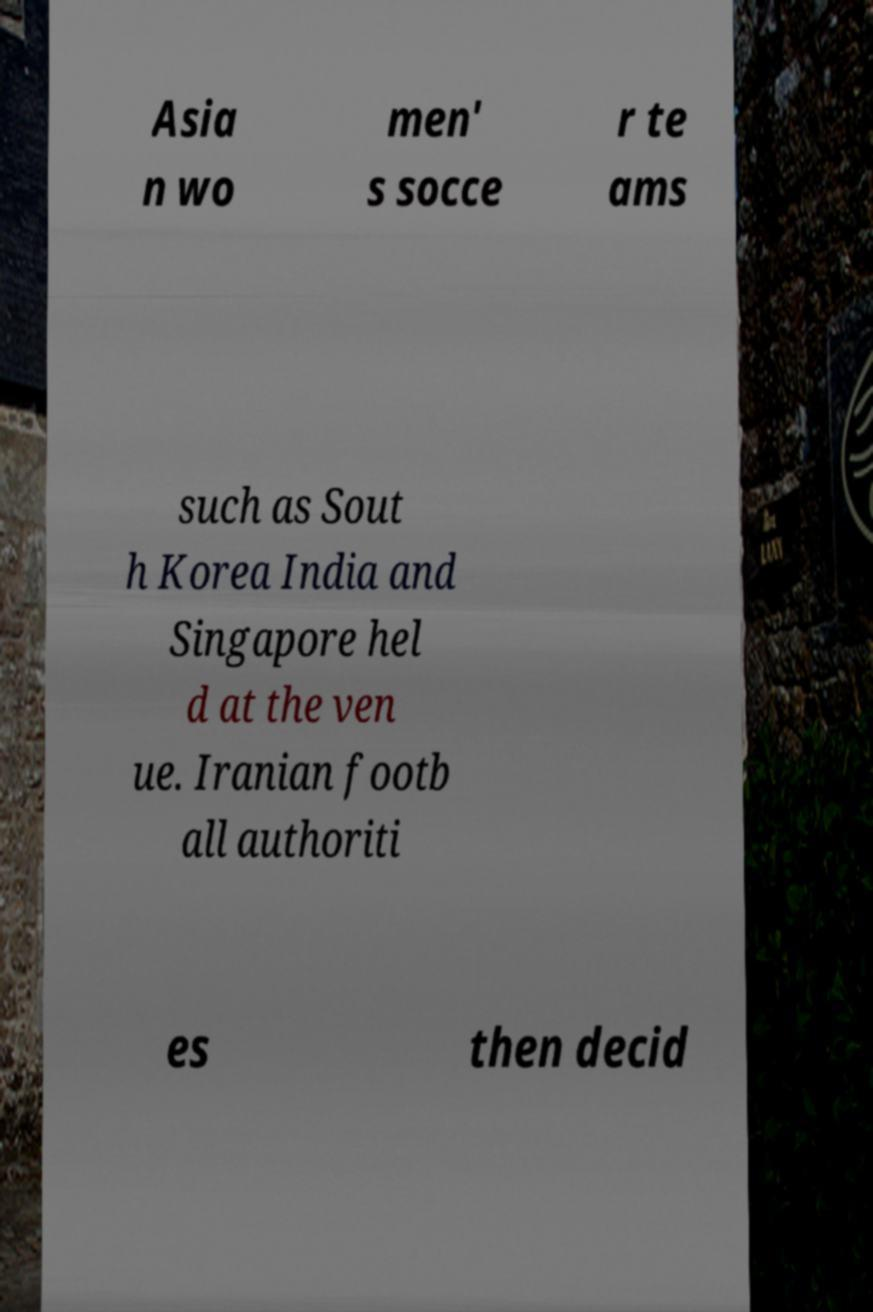Please identify and transcribe the text found in this image. Asia n wo men' s socce r te ams such as Sout h Korea India and Singapore hel d at the ven ue. Iranian footb all authoriti es then decid 